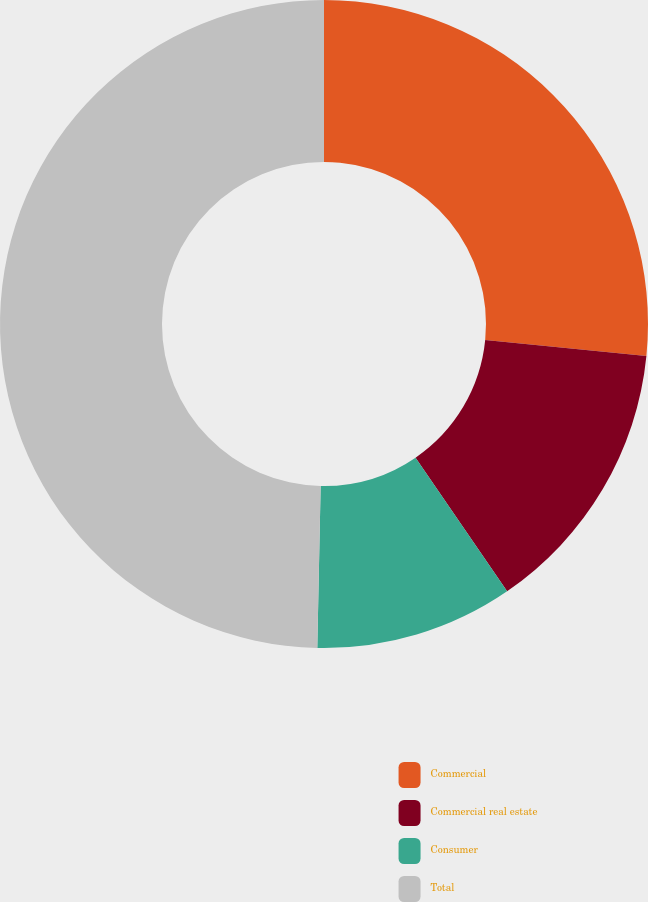Convert chart to OTSL. <chart><loc_0><loc_0><loc_500><loc_500><pie_chart><fcel>Commercial<fcel>Commercial real estate<fcel>Consumer<fcel>Total<nl><fcel>26.58%<fcel>13.86%<fcel>9.89%<fcel>49.67%<nl></chart> 